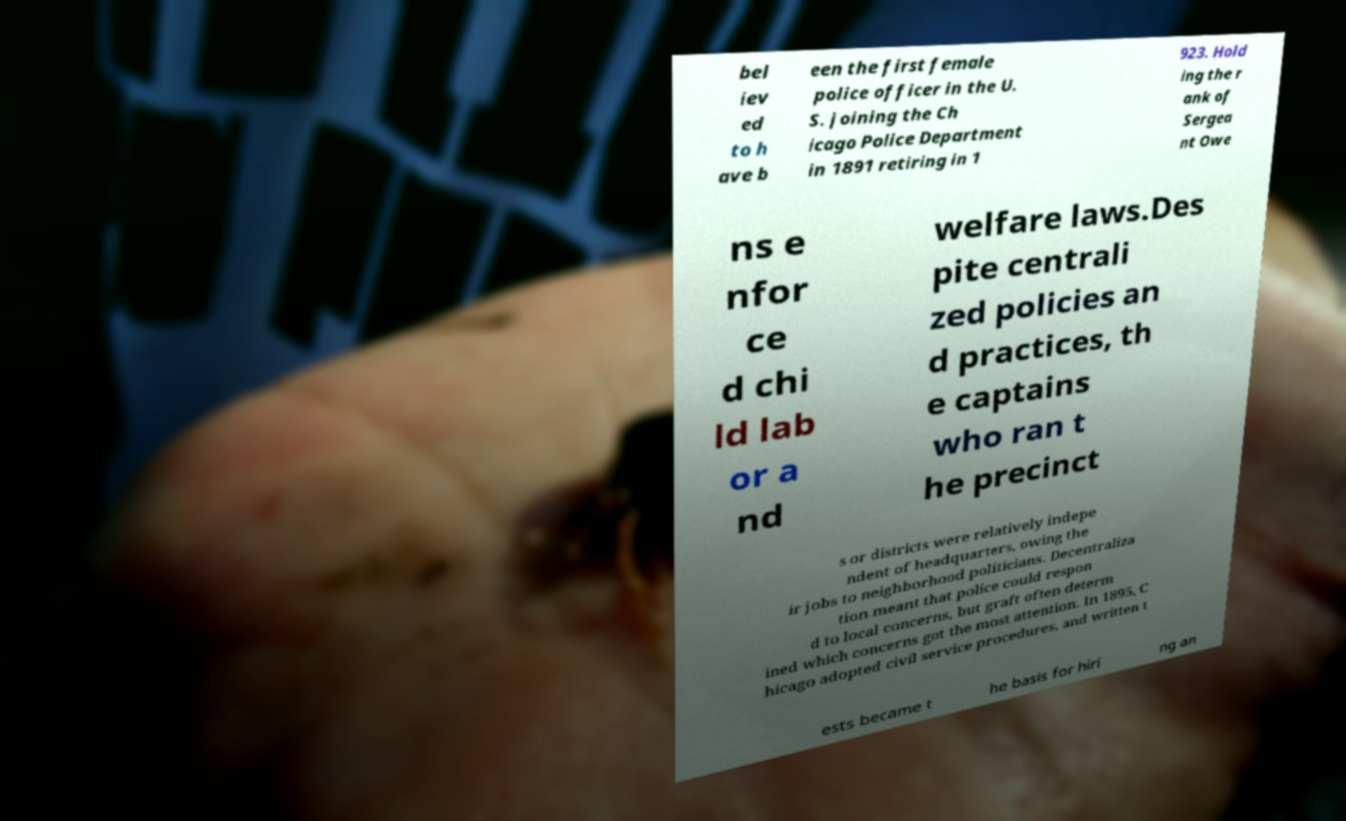There's text embedded in this image that I need extracted. Can you transcribe it verbatim? bel iev ed to h ave b een the first female police officer in the U. S. joining the Ch icago Police Department in 1891 retiring in 1 923. Hold ing the r ank of Sergea nt Owe ns e nfor ce d chi ld lab or a nd welfare laws.Des pite centrali zed policies an d practices, th e captains who ran t he precinct s or districts were relatively indepe ndent of headquarters, owing the ir jobs to neighborhood politicians. Decentraliza tion meant that police could respon d to local concerns, but graft often determ ined which concerns got the most attention. In 1895, C hicago adopted civil service procedures, and written t ests became t he basis for hiri ng an 